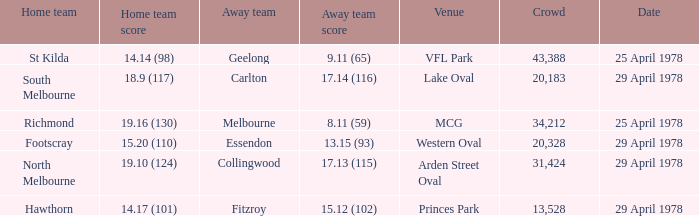In what venue was the hosted away team Essendon? Western Oval. 